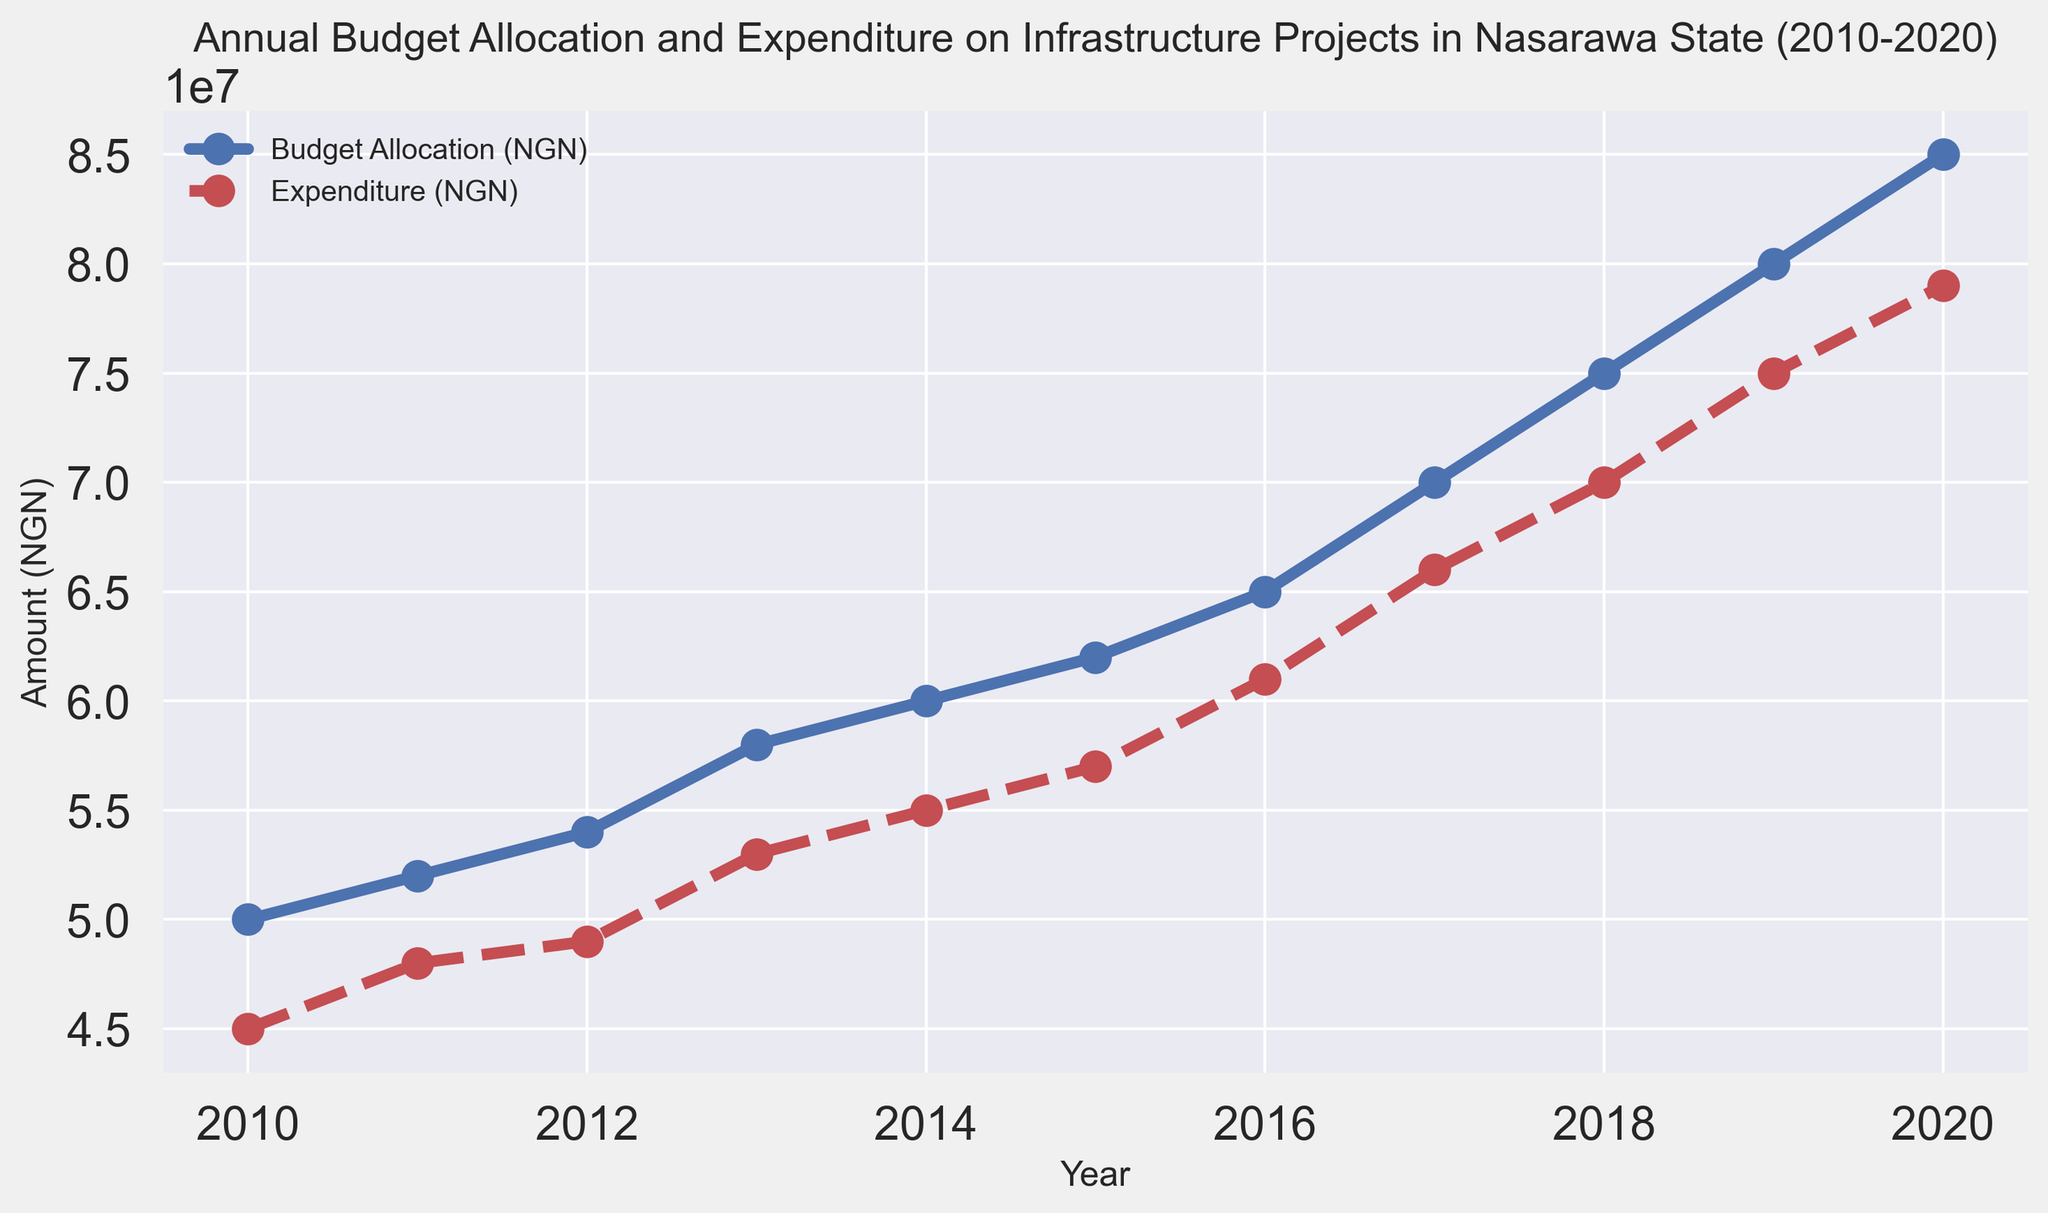What is the budget allocation in 2015? Refer to the line chart and look for the value of the "Budget Allocation (NGN)" point for the year 2015. The budget allocation is 62,000,000 NGN.
Answer: 62,000,000 NGN What was the trend in expenditure from 2010 to 2020? Analyze the line representing expenditure (red, dashed line). The line shows a consistently increasing trend from 45,000,000 NGN in 2010 to 79,000,000 NGN in 2020.
Answer: Increasing How much more was allocated in the budget compared to the expenditure in 2013? Find the values for "Budget Allocation" and "Expenditure" in 2013: 58,000,000 NGN and 53,000,000 NGN respectively. Compute the difference: 58,000,000 - 53,000,000 = 5,000,000 NGN.
Answer: 5,000,000 NGN What year had the greatest gap between budget allocation and expenditure? Compare the gaps for each year. The greatest gap is in 2020 with a difference of 8,000,000 NGN (85,000,000 NGN - 79,000,000 NGN).
Answer: 2020 What was the average expenditure from 2010 to 2020? Sum the expenditure values: 45,000,000 + 48,000,000 + 49,000,000 + 53,000,000 + 55,000,000 + 57,000,000 + 61,000,000 + 66,000,000 + 70,000,000 + 75,000,000 + 79,000,000 = 658,000,000 NGN. Divide by the number of years (11): 658,000,000 / 11 ≈ 59,818,181.82 NGN.
Answer: 59,818,181.82 NGN In how many years did expenditure exceed 50,000,000 NGN? Identify the years when expenditure values exceeded 50,000,000 NGN: from 2013 to 2020 (8 years).
Answer: 8 years Was there ever a year when expenditure decreased compared to the previous year? Check all expenditure values: they increase every year without any decrease.
Answer: No What is the overall growth in budget allocation from 2010 to 2020? Subtract the 2010 budget allocation from the 2020 budget allocation: 85,000,000 - 50,000,000 = 35,000,000 NGN.
Answer: 35,000,000 NGN Which year had the smallest difference between budget allocation and expenditure? Find the differences for each year and identify the smallest: 2011 has the smallest difference of 4,000,000 NGN (52,000,000 - 48,000,000).
Answer: 2011 